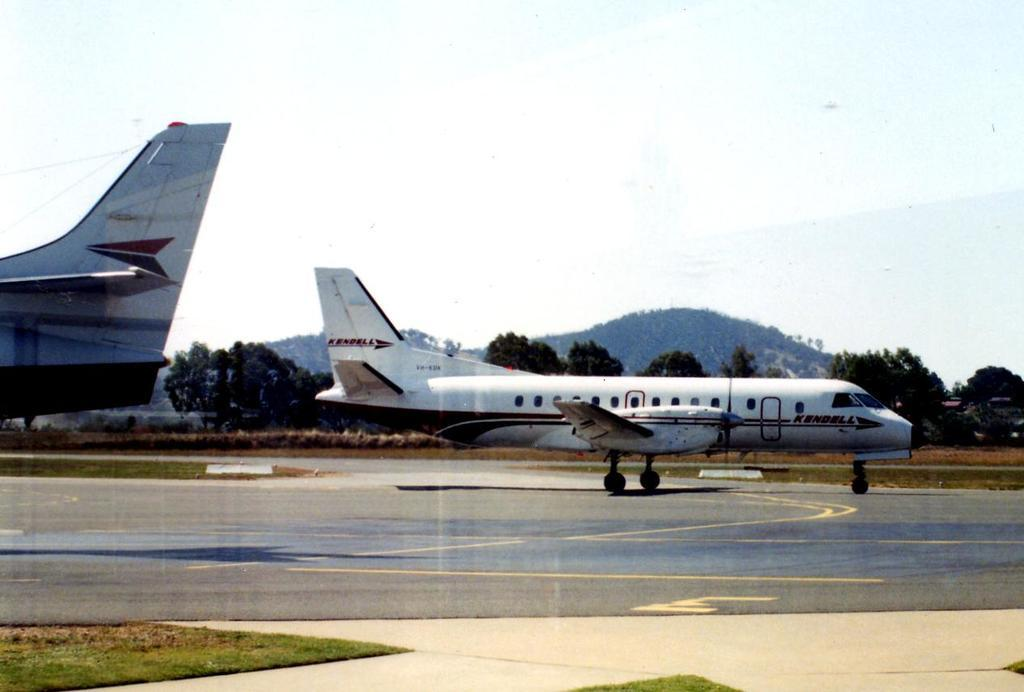<image>
Write a terse but informative summary of the picture. A Kendell passenger plane sits on the runway next to a much larger plane. 